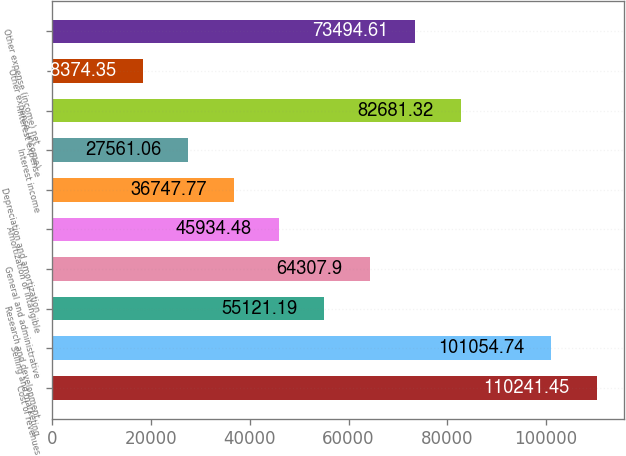Convert chart to OTSL. <chart><loc_0><loc_0><loc_500><loc_500><bar_chart><fcel>Cost of revenues<fcel>Selling and marketing<fcel>Research and development<fcel>General and administrative<fcel>Amortization of intangible<fcel>Depreciation and amortization<fcel>Interest income<fcel>Interest expense<fcel>Other expense (income)<fcel>Other expense (income) net<nl><fcel>110241<fcel>101055<fcel>55121.2<fcel>64307.9<fcel>45934.5<fcel>36747.8<fcel>27561.1<fcel>82681.3<fcel>18374.3<fcel>73494.6<nl></chart> 